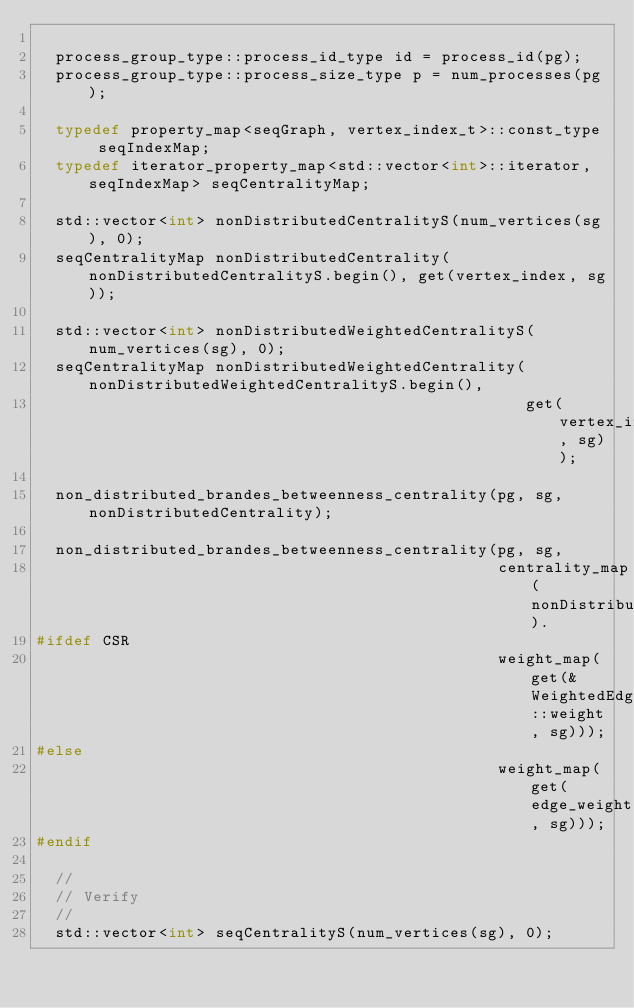<code> <loc_0><loc_0><loc_500><loc_500><_C++_>
  process_group_type::process_id_type id = process_id(pg);
  process_group_type::process_size_type p = num_processes(pg);    

  typedef property_map<seqGraph, vertex_index_t>::const_type seqIndexMap;
  typedef iterator_property_map<std::vector<int>::iterator, seqIndexMap> seqCentralityMap;

  std::vector<int> nonDistributedCentralityS(num_vertices(sg), 0);
  seqCentralityMap nonDistributedCentrality(nonDistributedCentralityS.begin(), get(vertex_index, sg));

  std::vector<int> nonDistributedWeightedCentralityS(num_vertices(sg), 0);
  seqCentralityMap nonDistributedWeightedCentrality(nonDistributedWeightedCentralityS.begin(), 
                                                    get(vertex_index, sg));

  non_distributed_brandes_betweenness_centrality(pg, sg, nonDistributedCentrality);

  non_distributed_brandes_betweenness_centrality(pg, sg, 
                                                 centrality_map(nonDistributedWeightedCentrality).
#ifdef CSR
                                                 weight_map(get(&WeightedEdge::weight, sg)));
#else
                                                 weight_map(get(edge_weight, sg)));
#endif

  //
  // Verify
  //
  std::vector<int> seqCentralityS(num_vertices(sg), 0);</code> 